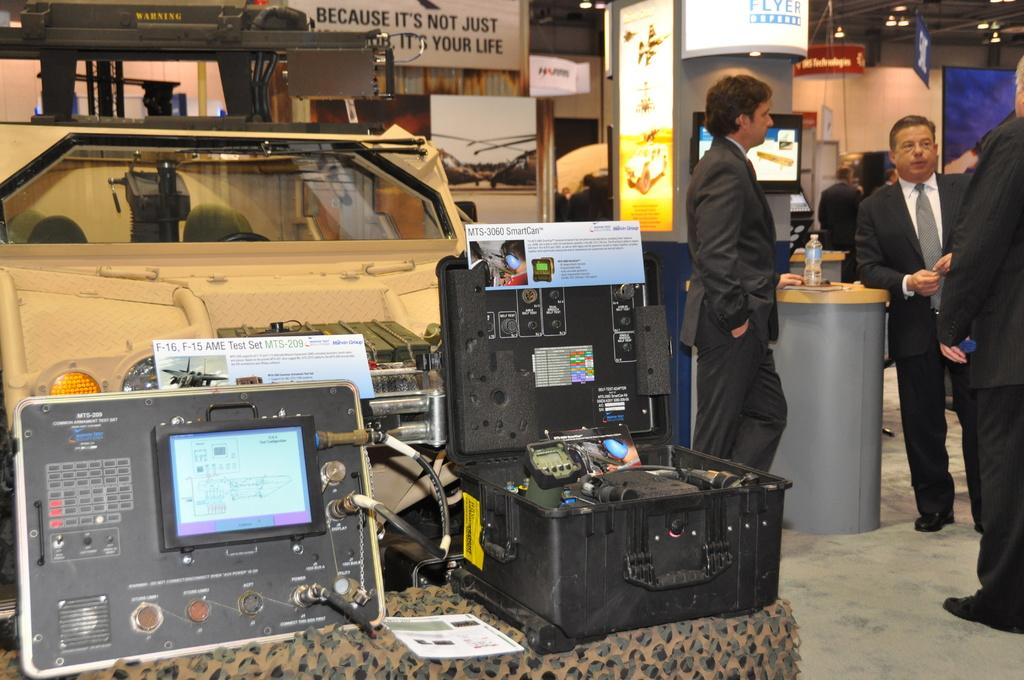What are the people in the image doing? The persons standing on the floor are likely engaged in some activity or standing near the devices. Can you describe the devices in the image? There are devices in the image, but their specific purpose or appearance cannot be determined from the facts provided. What type of material is present in the image? Cloth, boards, and a screen are present in the image. What is the bottle in the image used for? The purpose of the bottle in the image cannot be determined from the facts provided. What type of lighting is present in the image? There are lights in the image, but their specific type or intensity cannot be determined from the facts provided. What can be seen in the background of the image? There is a wall in the background of the image. How many cows are present in the image? There are no cows present in the image. What type of brass instrument is being played in the image? There is no brass instrument present in the image. 